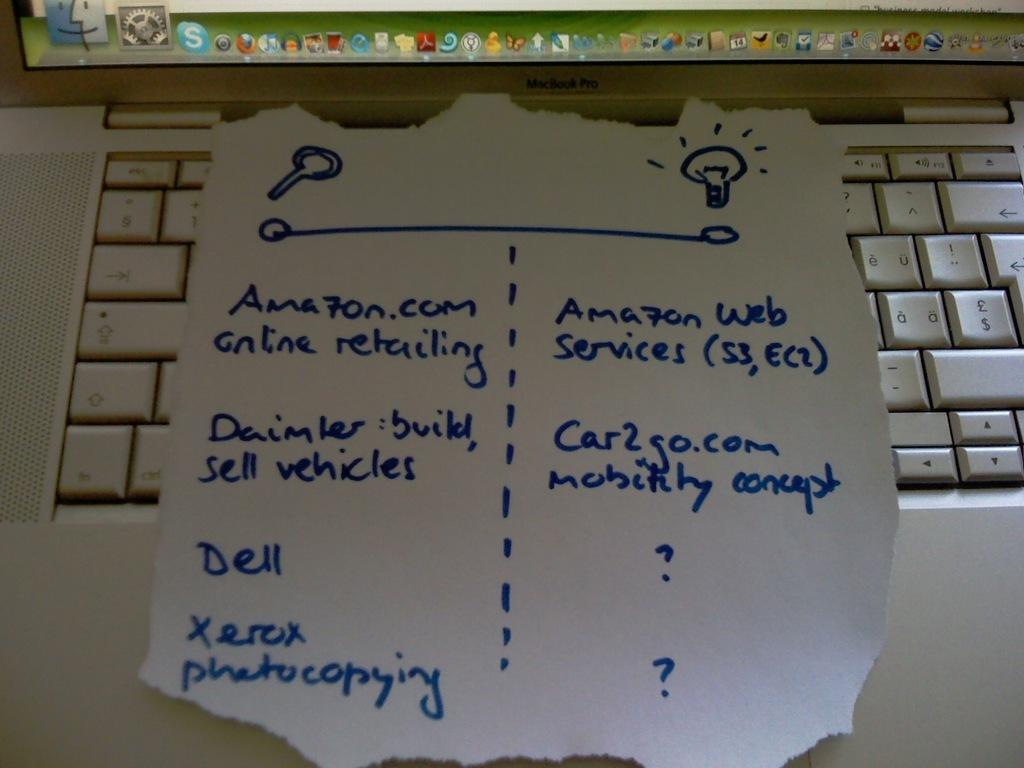<image>
Summarize the visual content of the image. A piece of paper which references Amazon Web Services is on top of a MacBook Pro keyboard. 